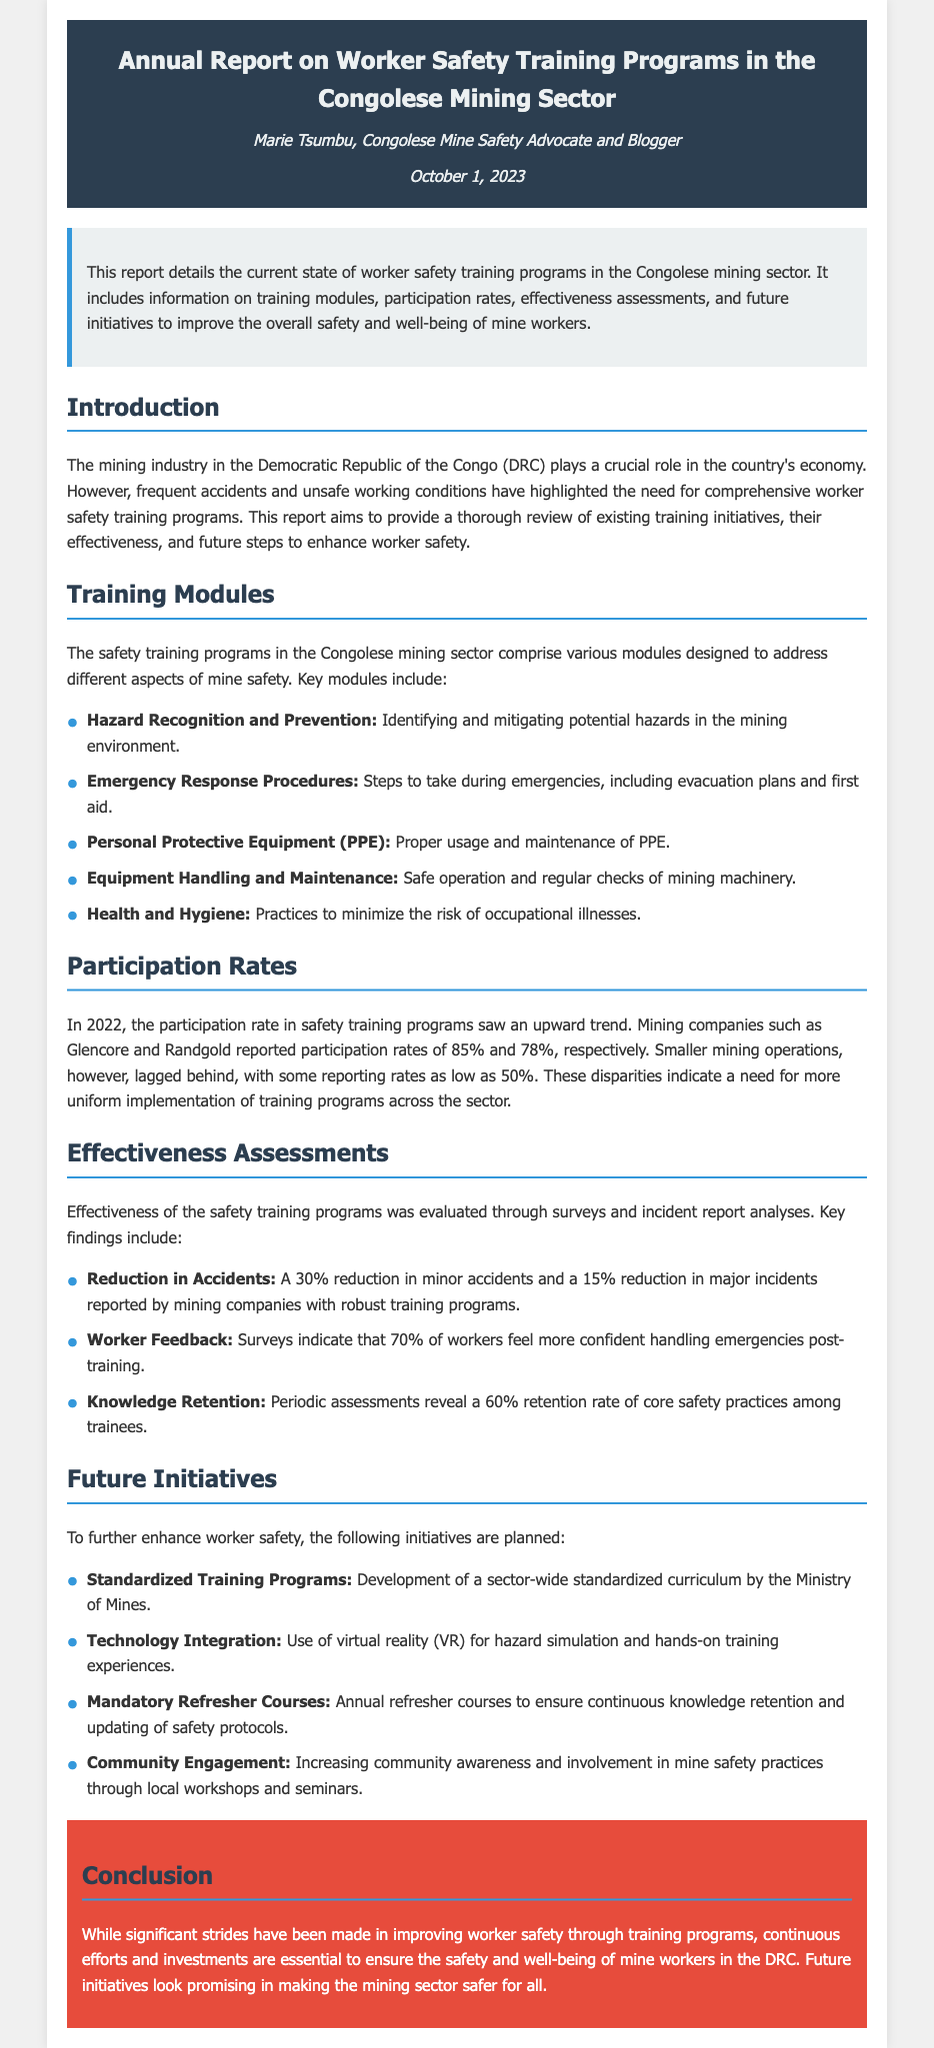What is the author of the report? The author of the report is Marie Tsumbu, as mentioned in the header.
Answer: Marie Tsumbu What is the date of the report? The date of the report is stated in the header section.
Answer: October 1, 2023 What is one key module of the training programs? The document lists several modules, one of which is Hazard Recognition and Prevention.
Answer: Hazard Recognition and Prevention What was the participation rate for Glencore? The report specifies that Glencore reported a participation rate of 85%.
Answer: 85% What percentage of workers feel more confident after training? According to the worker feedback in the report, 70% feel more confident.
Answer: 70% What is one future initiative planned for worker safety? The report highlights developing standardized training programs as a future initiative.
Answer: Standardized Training Programs What reduction in major incidents was reported? The effectiveness assessment states a 15% reduction in major incidents.
Answer: 15% What technology is planned for integration into training? The report mentions the use of virtual reality (VR) for training simulations.
Answer: Virtual reality (VR) What was the knowledge retention rate among trainees? The document indicates a 60% retention rate of core safety practices.
Answer: 60% What color is used for the conclusion section? The conclusion section is specified to have a background color of red.
Answer: Red 